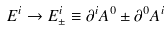<formula> <loc_0><loc_0><loc_500><loc_500>E ^ { i } \rightarrow E ^ { i } _ { \pm } \equiv \partial ^ { i } A ^ { 0 } \pm \partial ^ { 0 } A ^ { i }</formula> 